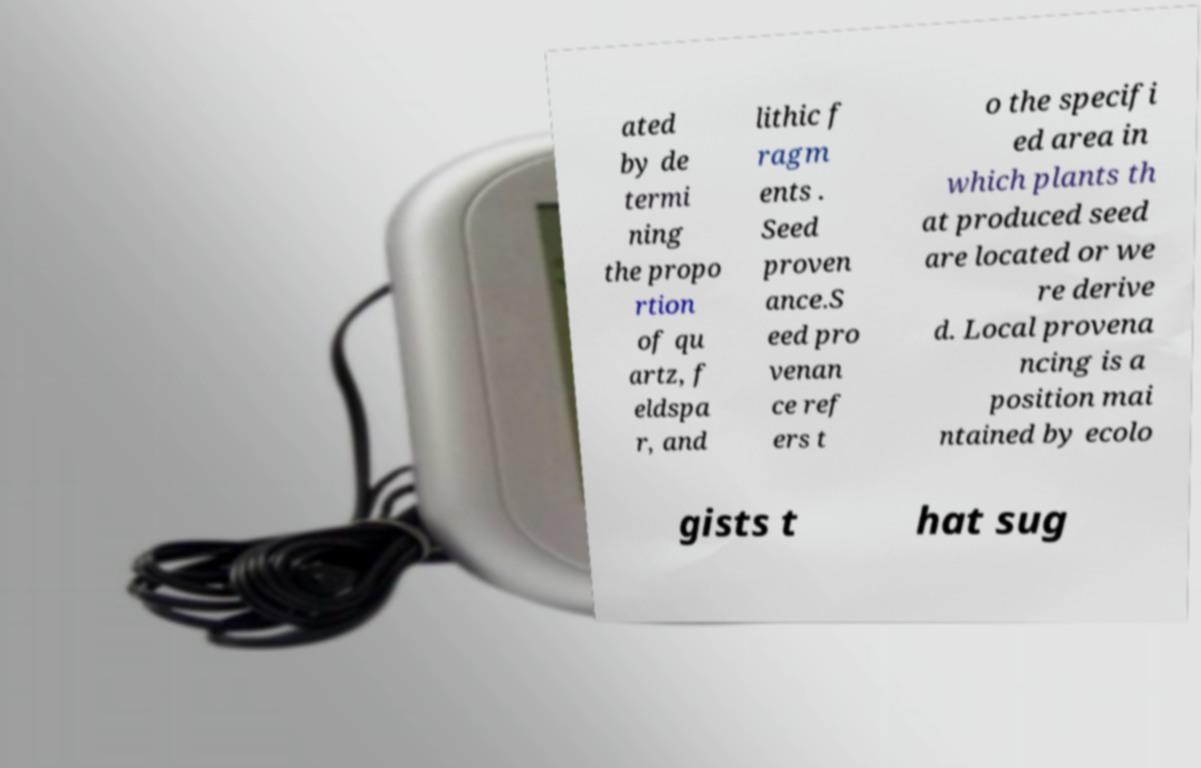For documentation purposes, I need the text within this image transcribed. Could you provide that? ated by de termi ning the propo rtion of qu artz, f eldspa r, and lithic f ragm ents . Seed proven ance.S eed pro venan ce ref ers t o the specifi ed area in which plants th at produced seed are located or we re derive d. Local provena ncing is a position mai ntained by ecolo gists t hat sug 